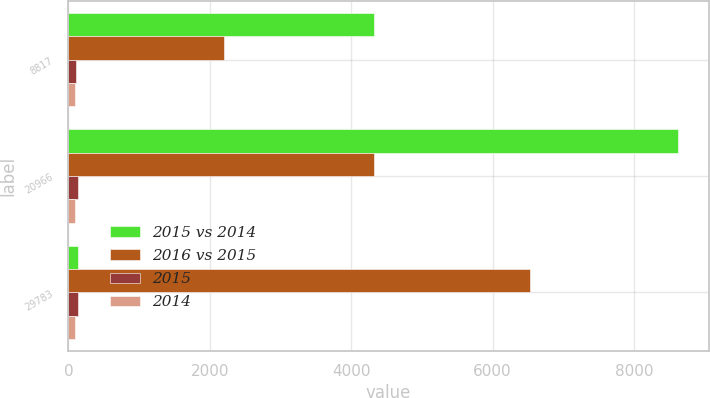Convert chart. <chart><loc_0><loc_0><loc_500><loc_500><stacked_bar_chart><ecel><fcel>8817<fcel>20966<fcel>29783<nl><fcel>2015 vs 2014<fcel>4317<fcel>8627<fcel>143<nl><fcel>2016 vs 2015<fcel>2204<fcel>4325<fcel>6529<nl><fcel>2015<fcel>104<fcel>143<fcel>130<nl><fcel>2014<fcel>96<fcel>99<fcel>98<nl></chart> 